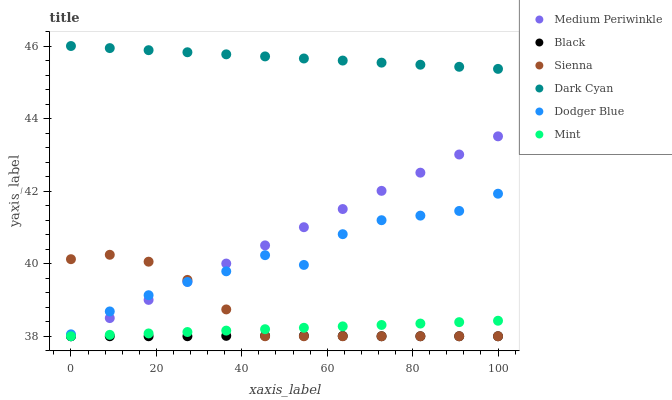Does Black have the minimum area under the curve?
Answer yes or no. Yes. Does Dark Cyan have the maximum area under the curve?
Answer yes or no. Yes. Does Sienna have the minimum area under the curve?
Answer yes or no. No. Does Sienna have the maximum area under the curve?
Answer yes or no. No. Is Dark Cyan the smoothest?
Answer yes or no. Yes. Is Dodger Blue the roughest?
Answer yes or no. Yes. Is Sienna the smoothest?
Answer yes or no. No. Is Sienna the roughest?
Answer yes or no. No. Does Medium Periwinkle have the lowest value?
Answer yes or no. Yes. Does Dark Cyan have the lowest value?
Answer yes or no. No. Does Dark Cyan have the highest value?
Answer yes or no. Yes. Does Sienna have the highest value?
Answer yes or no. No. Is Black less than Dark Cyan?
Answer yes or no. Yes. Is Dodger Blue greater than Black?
Answer yes or no. Yes. Does Black intersect Mint?
Answer yes or no. Yes. Is Black less than Mint?
Answer yes or no. No. Is Black greater than Mint?
Answer yes or no. No. Does Black intersect Dark Cyan?
Answer yes or no. No. 